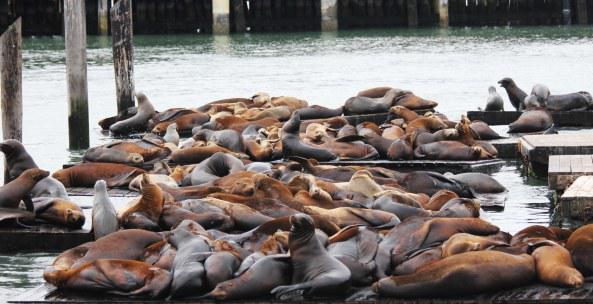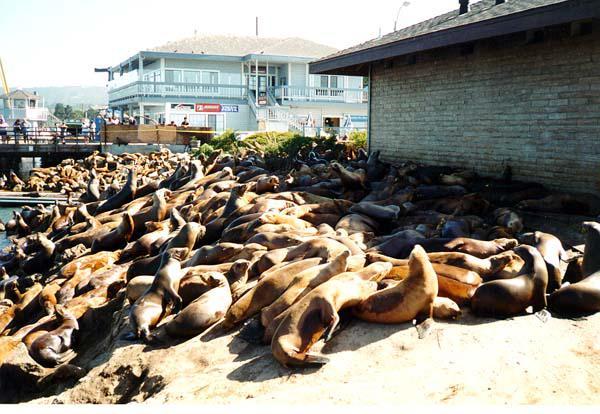The first image is the image on the left, the second image is the image on the right. Assess this claim about the two images: "The corners of floating platforms piled with reclining seals are visible in just one image.". Correct or not? Answer yes or no. Yes. The first image is the image on the left, the second image is the image on the right. Examine the images to the left and right. Is the description "In at least one of the images, there are vertical wooden poles sticking up from the docks." accurate? Answer yes or no. Yes. 